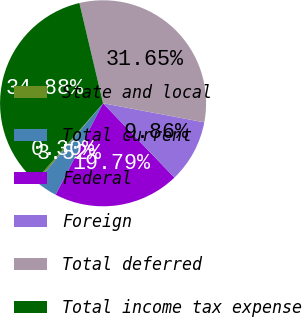<chart> <loc_0><loc_0><loc_500><loc_500><pie_chart><fcel>State and local<fcel>Total current<fcel>Federal<fcel>Foreign<fcel>Total deferred<fcel>Total income tax expense<nl><fcel>0.3%<fcel>3.52%<fcel>19.79%<fcel>9.86%<fcel>31.65%<fcel>34.88%<nl></chart> 